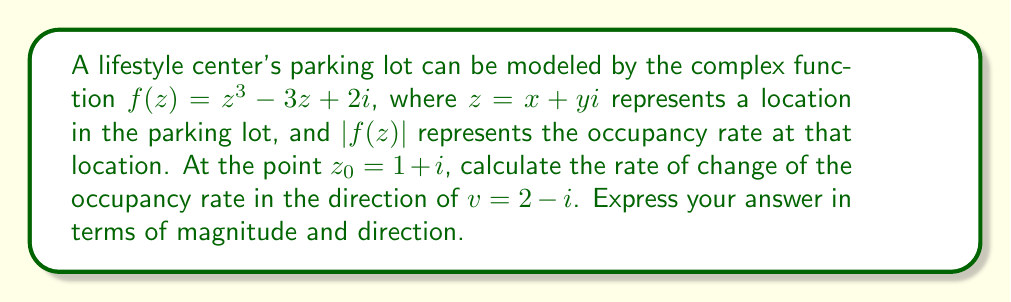Teach me how to tackle this problem. To solve this problem, we need to use the concept of directional derivatives in complex analysis. The steps are as follows:

1) First, we need to calculate the complex derivative of $f(z)$ at $z_0 = 1 + i$:

   $f'(z) = 3z^2 - 3$
   $f'(1+i) = 3(1+i)^2 - 3 = 3(1+2i-1) - 3 = 3(2i) - 3 = 6i - 3$

2) The directional derivative in the direction of $v = 2 - i$ is given by:

   $D_v f(z_0) = f'(z_0) \cdot \frac{v}{|v|}$

3) We need to normalize the vector $v$:

   $|v| = \sqrt{2^2 + (-1)^2} = \sqrt{5}$
   $\frac{v}{|v|} = \frac{2-i}{\sqrt{5}}$

4) Now we can calculate the directional derivative:

   $D_v f(1+i) = (6i-3) \cdot \frac{2-i}{\sqrt{5}}$

5) Multiply these complex numbers:

   $D_v f(1+i) = \frac{(6i-3)(2-i)}{\sqrt{5}} = \frac{12i-6-6i^2+3i}{\sqrt{5}} = \frac{12i-6+6+3i}{\sqrt{5}} = \frac{15i}{\sqrt{5}}$

6) To express this in terms of magnitude and direction, we can write it in polar form:

   $\frac{15i}{\sqrt{5}} = \frac{15}{\sqrt{5}} \cdot (\cos(\frac{\pi}{2}) + i\sin(\frac{\pi}{2})) = 3\sqrt{5} \cdot e^{i\frac{\pi}{2}}$
Answer: The rate of change of the occupancy rate at $z_0 = 1 + i$ in the direction of $v = 2 - i$ is $3\sqrt{5} \cdot e^{i\frac{\pi}{2}}$, which has a magnitude of $3\sqrt{5}$ and a direction of $\frac{\pi}{2}$ radians (or 90 degrees) counterclockwise from the positive real axis. 